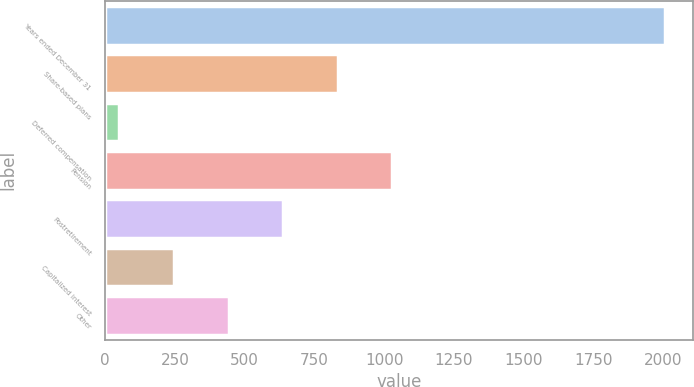<chart> <loc_0><loc_0><loc_500><loc_500><bar_chart><fcel>Years ended December 31<fcel>Share-based plans<fcel>Deferred compensation<fcel>Pension<fcel>Postretirement<fcel>Capitalized interest<fcel>Other<nl><fcel>2007<fcel>833.4<fcel>51<fcel>1029<fcel>637.8<fcel>246.6<fcel>442.2<nl></chart> 